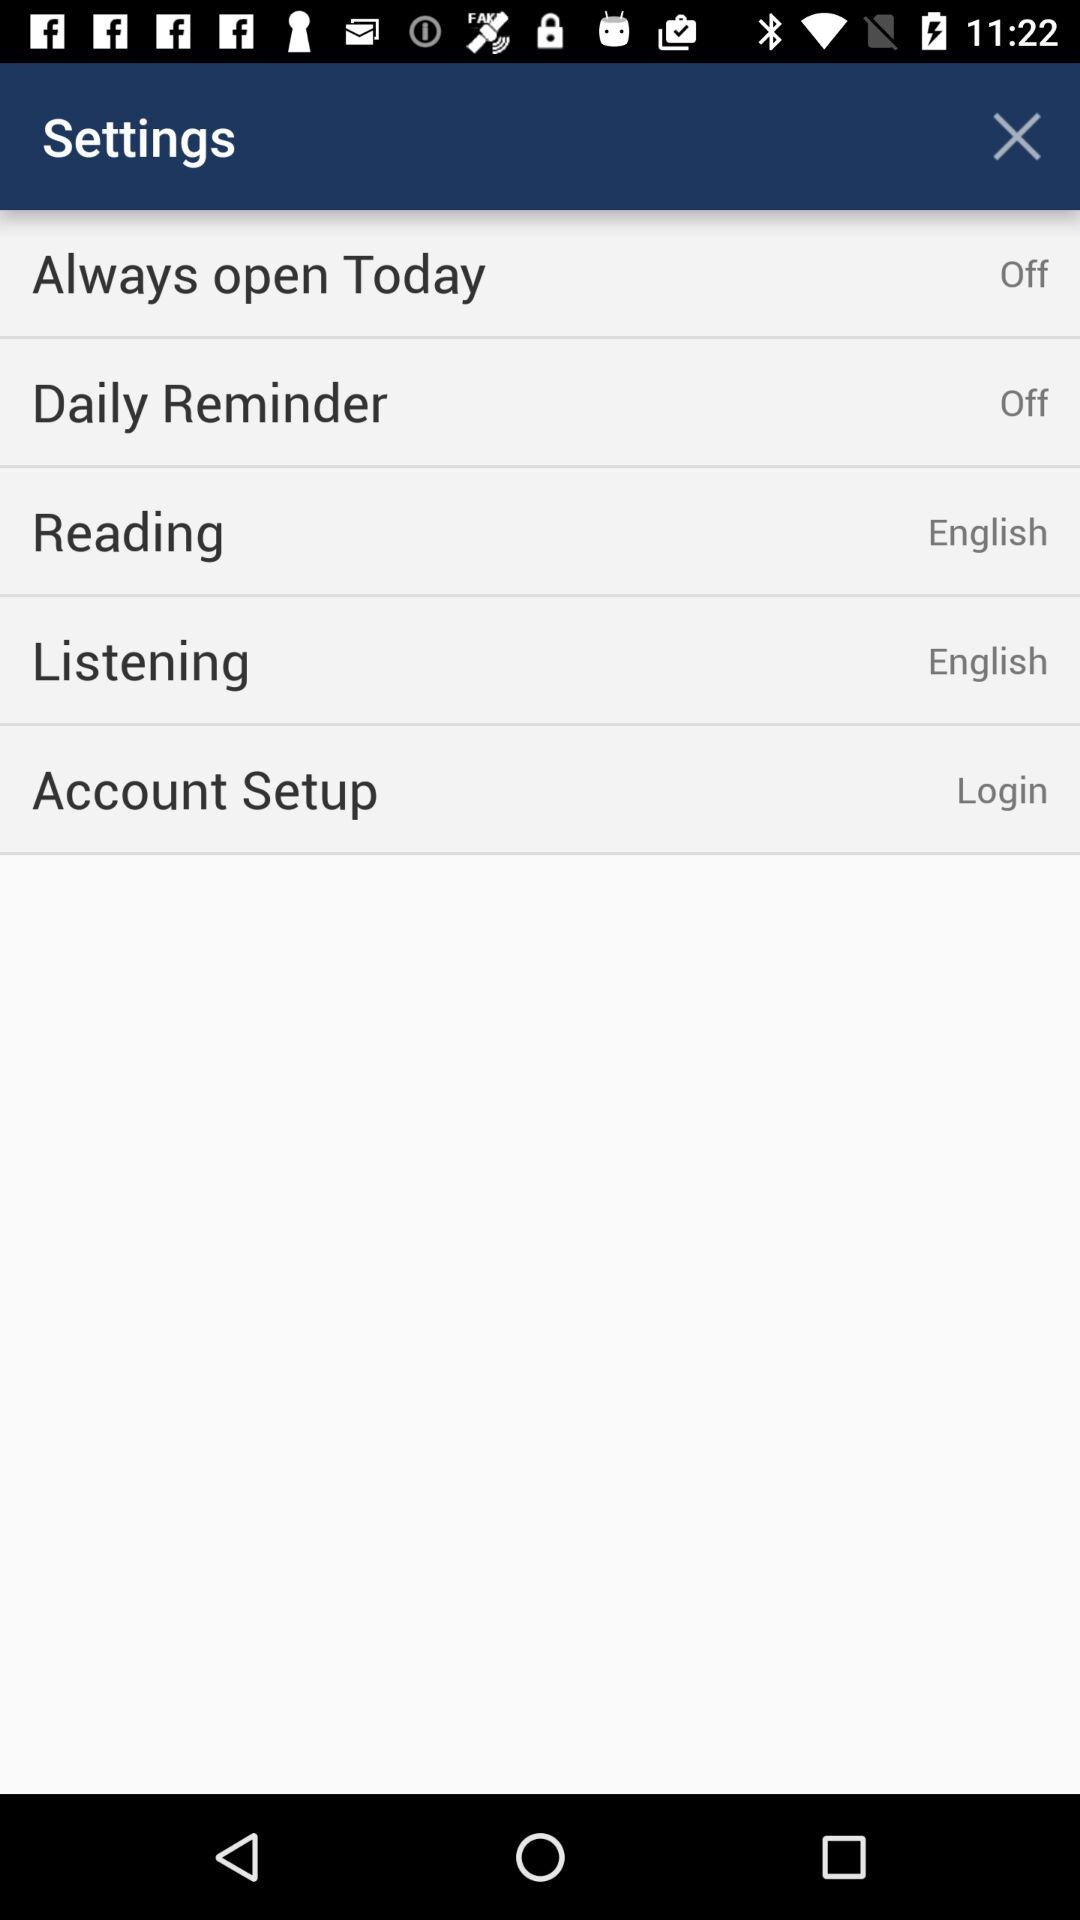What is the selected listening language? The selected listening language is English. 